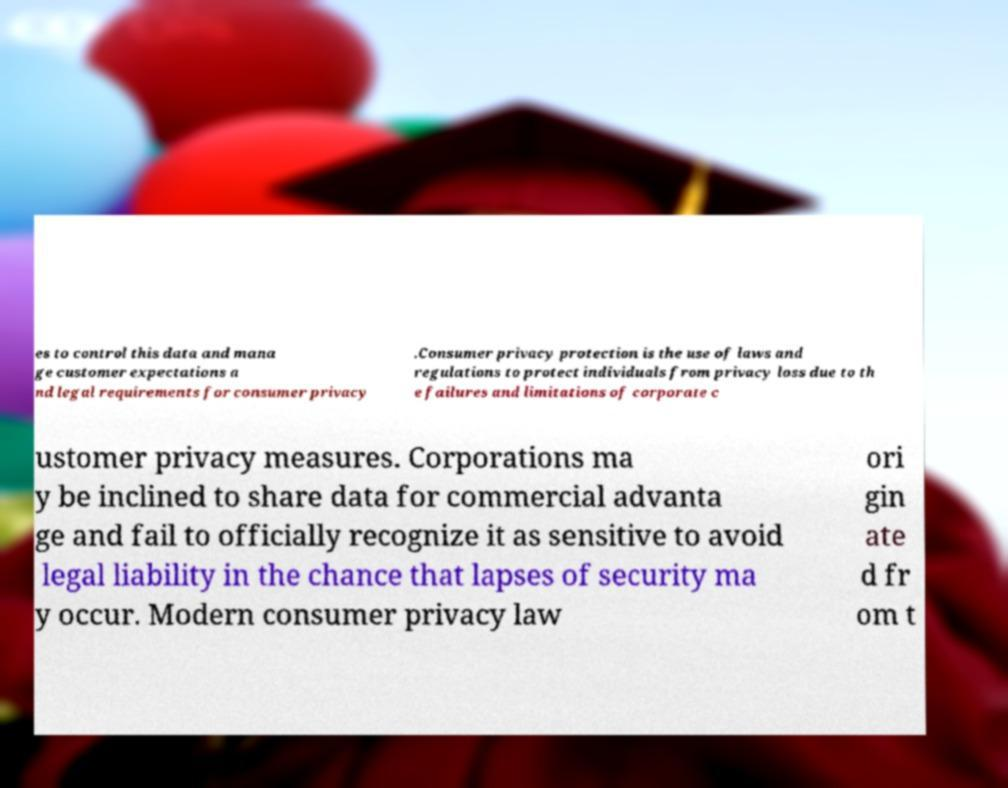Could you assist in decoding the text presented in this image and type it out clearly? es to control this data and mana ge customer expectations a nd legal requirements for consumer privacy .Consumer privacy protection is the use of laws and regulations to protect individuals from privacy loss due to th e failures and limitations of corporate c ustomer privacy measures. Corporations ma y be inclined to share data for commercial advanta ge and fail to officially recognize it as sensitive to avoid legal liability in the chance that lapses of security ma y occur. Modern consumer privacy law ori gin ate d fr om t 